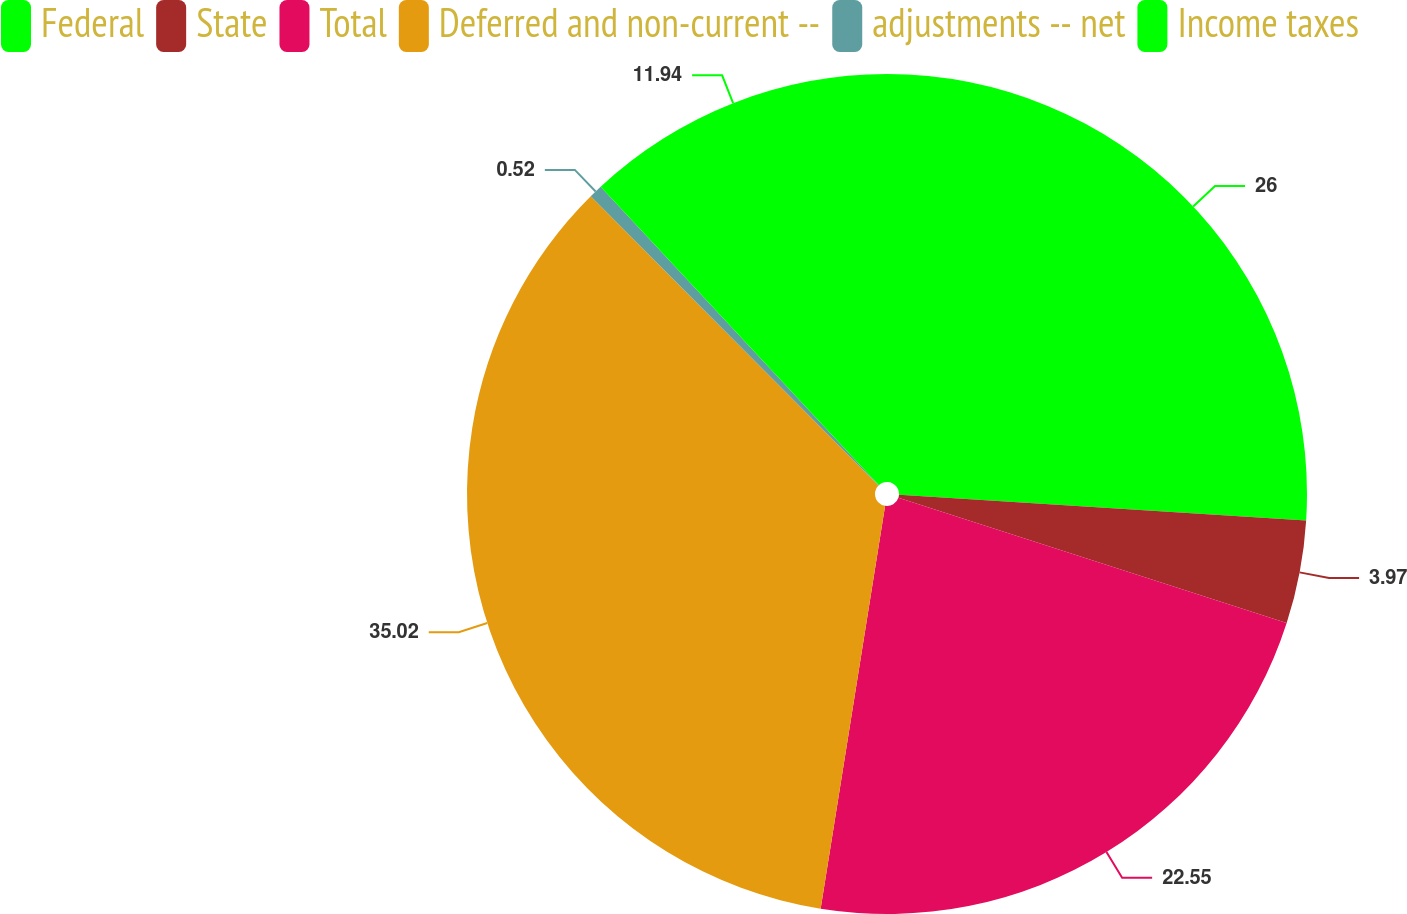<chart> <loc_0><loc_0><loc_500><loc_500><pie_chart><fcel>Federal<fcel>State<fcel>Total<fcel>Deferred and non-current --<fcel>adjustments -- net<fcel>Income taxes<nl><fcel>26.0%<fcel>3.97%<fcel>22.55%<fcel>35.01%<fcel>0.52%<fcel>11.94%<nl></chart> 